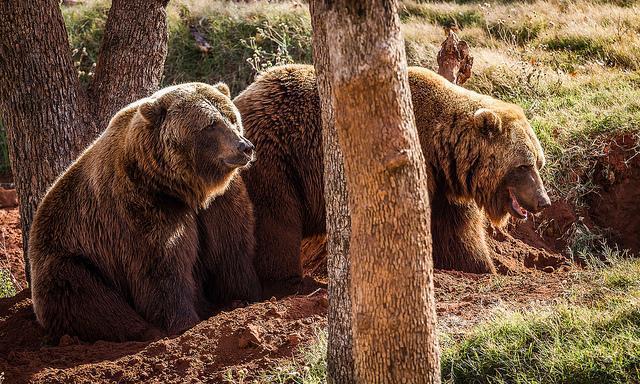How many animals are in this image?
Give a very brief answer. 2. How many bears are there?
Give a very brief answer. 2. 